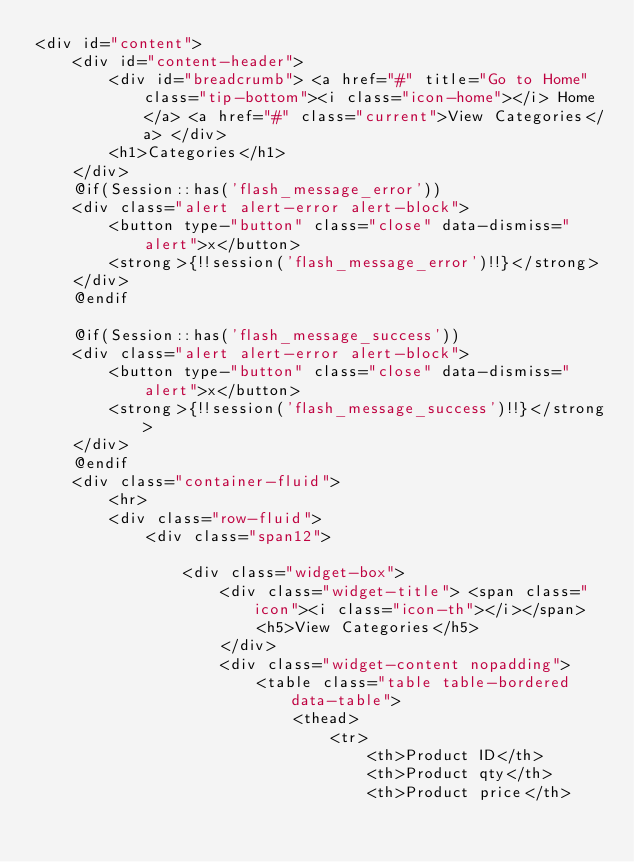Convert code to text. <code><loc_0><loc_0><loc_500><loc_500><_PHP_><div id="content">
    <div id="content-header">
        <div id="breadcrumb"> <a href="#" title="Go to Home" class="tip-bottom"><i class="icon-home"></i> Home</a> <a href="#" class="current">View Categories</a> </div>
        <h1>Categories</h1>
    </div>
    @if(Session::has('flash_message_error'))
    <div class="alert alert-error alert-block">
        <button type-"button" class="close" data-dismiss="alert">x</button>
        <strong>{!!session('flash_message_error')!!}</strong>
    </div>
    @endif

    @if(Session::has('flash_message_success'))
    <div class="alert alert-error alert-block">
        <button type-"button" class="close" data-dismiss="alert">x</button>
        <strong>{!!session('flash_message_success')!!}</strong>
    </div>
    @endif
    <div class="container-fluid">
        <hr>
        <div class="row-fluid">
            <div class="span12">

                <div class="widget-box">
                    <div class="widget-title"> <span class="icon"><i class="icon-th"></i></span>
                        <h5>View Categories</h5>
                    </div>
                    <div class="widget-content nopadding">
                        <table class="table table-bordered data-table">
                            <thead>
                                <tr>
                                    <th>Product ID</th>
                                    <th>Product qty</th>
                                    <th>Product price</th></code> 